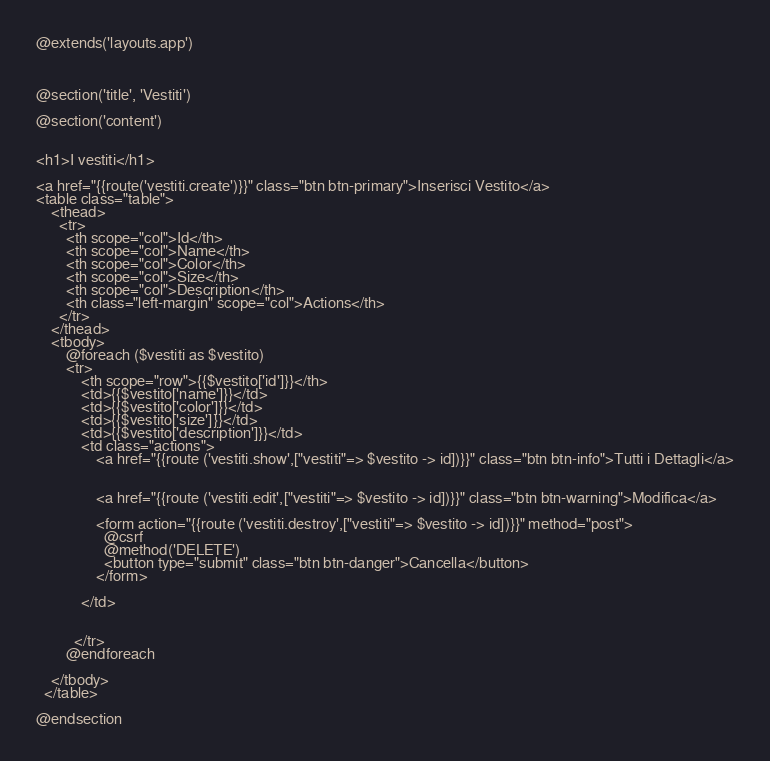<code> <loc_0><loc_0><loc_500><loc_500><_PHP_>@extends('layouts.app')



@section('title', 'Vestiti')

@section('content')


<h1>I vestiti</h1> 

<a href="{{route('vestiti.create')}}" class="btn btn-primary">Inserisci Vestito</a>
<table class="table">
    <thead>
      <tr>
        <th scope="col">Id</th>
        <th scope="col">Name</th>
        <th scope="col">Color</th>
        <th scope="col">Size</th>
        <th scope="col">Description</th>
        <th class="left-margin" scope="col">Actions</th>
      </tr>
    </thead>
    <tbody>
        @foreach ($vestiti as $vestito)
        <tr>
            <th scope="row">{{$vestito['id']}}</th>
            <td>{{$vestito['name']}}</td>
            <td>{{$vestito['color']}}</td>
            <td>{{$vestito['size']}}</td>
            <td>{{$vestito['description']}}</td>
            <td class="actions">
                <a href="{{route ('vestiti.show',["vestiti"=> $vestito -> id])}}" class="btn btn-info">Tutti i Dettagli</a>

                
                <a href="{{route ('vestiti.edit',["vestiti"=> $vestito -> id])}}" class="btn btn-warning">Modifica</a>

                <form action="{{route ('vestiti.destroy',["vestiti"=> $vestito -> id])}}" method="post">
                  @csrf
                  @method('DELETE')
                  <button type="submit" class="btn btn-danger">Cancella</button>
                </form>
              
            </td>

            
          </tr>  
        @endforeach

    </tbody>
  </table>

@endsection
</code> 